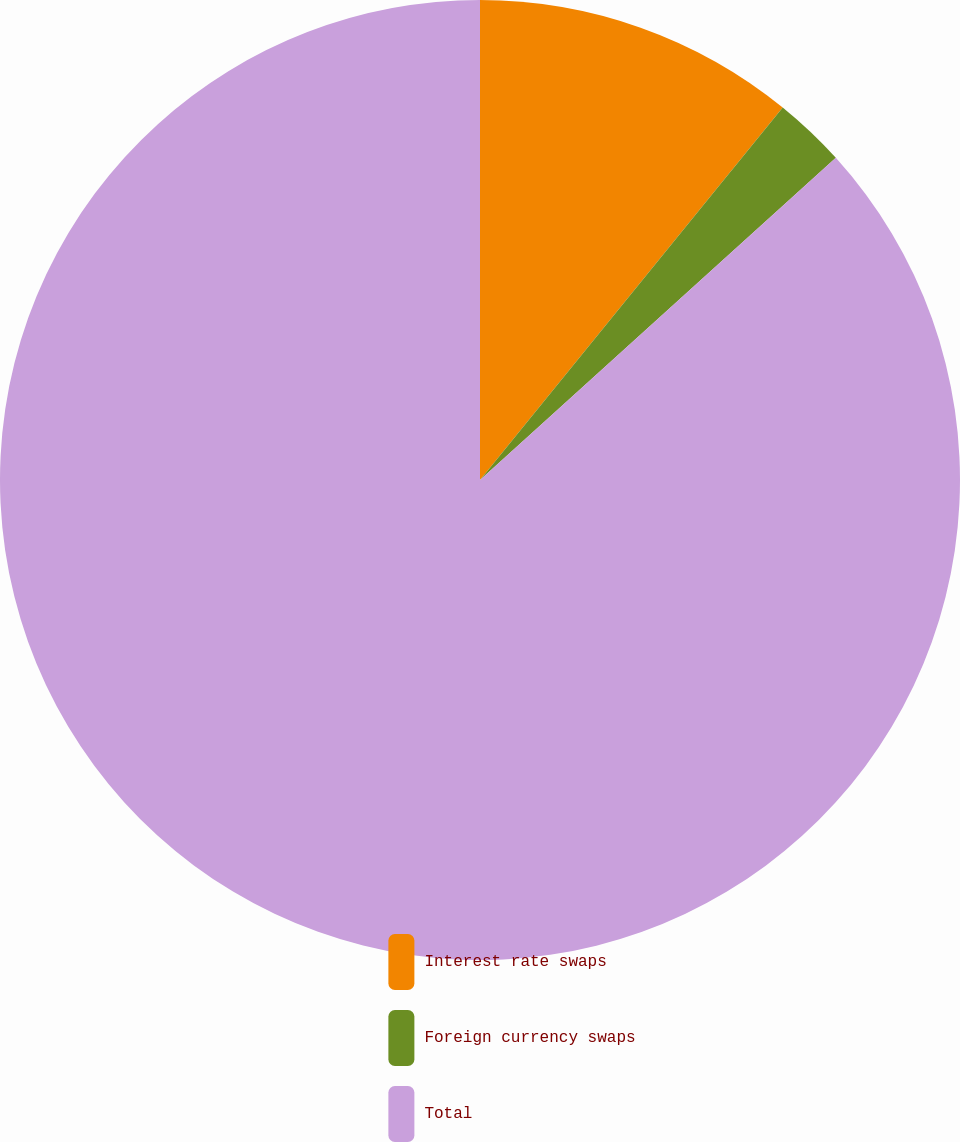Convert chart. <chart><loc_0><loc_0><loc_500><loc_500><pie_chart><fcel>Interest rate swaps<fcel>Foreign currency swaps<fcel>Total<nl><fcel>10.86%<fcel>2.43%<fcel>86.71%<nl></chart> 